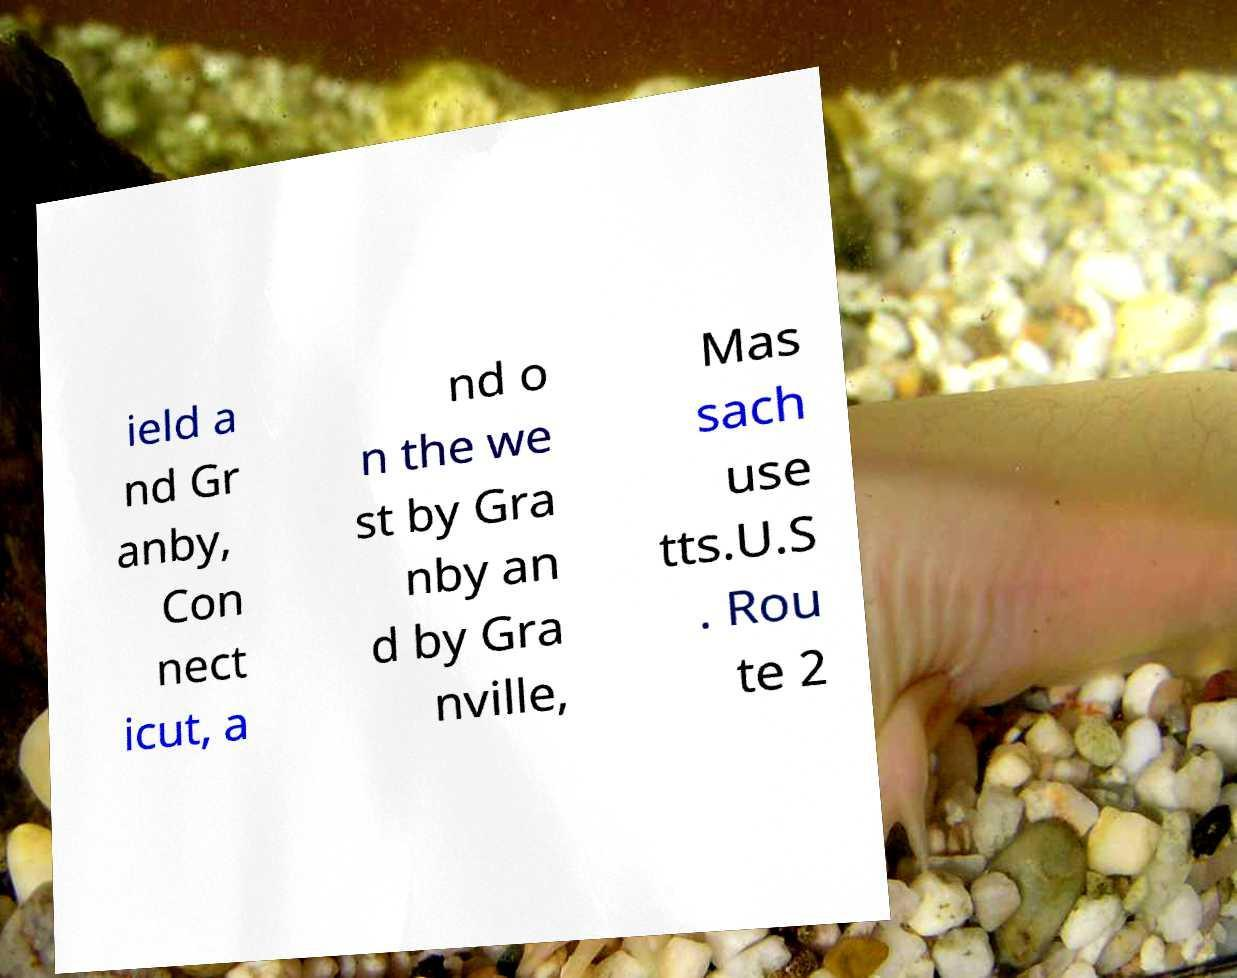What messages or text are displayed in this image? I need them in a readable, typed format. ield a nd Gr anby, Con nect icut, a nd o n the we st by Gra nby an d by Gra nville, Mas sach use tts.U.S . Rou te 2 